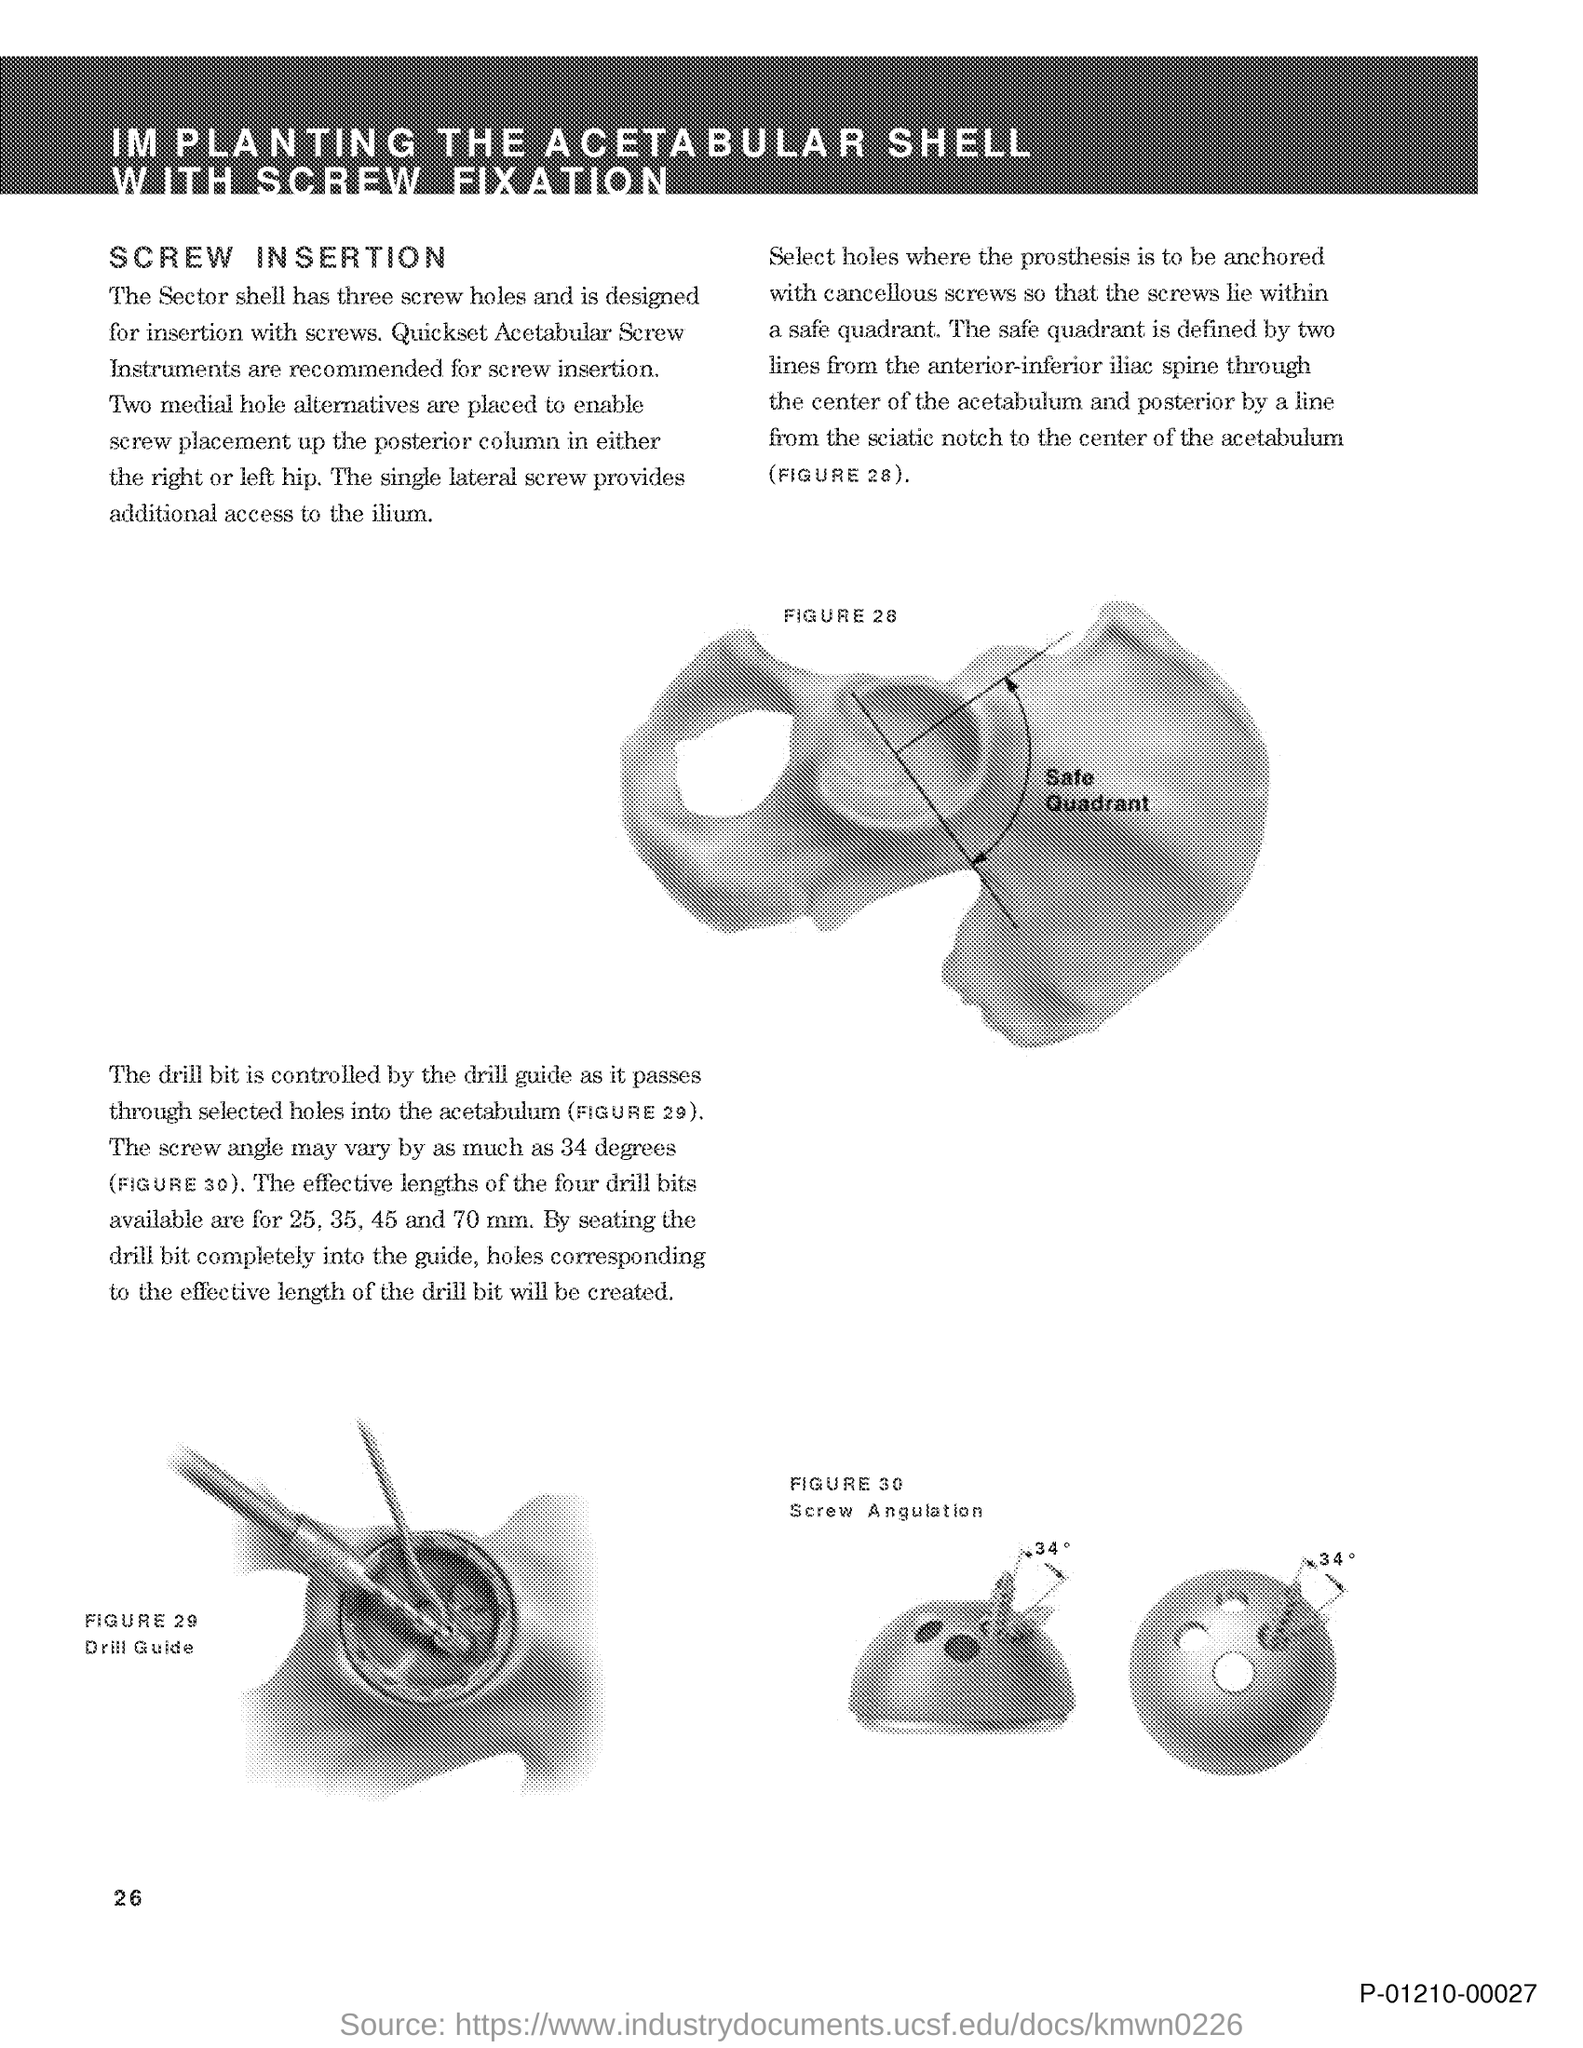Identify some key points in this picture. The title of this document is 'Implanting the Acetabular Shell with Screw Fixation.' 